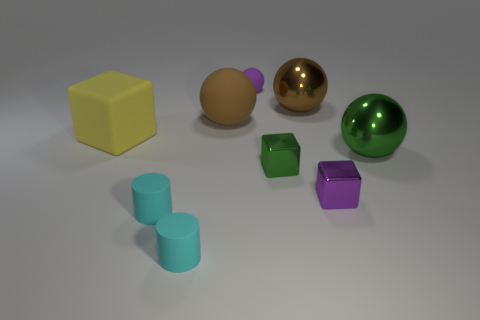What shape is the green thing that is left of the large shiny object that is behind the big block?
Ensure brevity in your answer.  Cube. There is another small object that is the same shape as the small green thing; what is its color?
Ensure brevity in your answer.  Purple. There is a big rubber ball; is its color the same as the large metal object that is behind the green sphere?
Offer a terse response. Yes. What shape is the metal object that is in front of the brown rubber ball and behind the small green object?
Your answer should be compact. Sphere. Is the number of green metallic spheres less than the number of cyan matte cylinders?
Offer a very short reply. Yes. Is there a red metal cylinder?
Ensure brevity in your answer.  No. What number of other objects are there of the same size as the purple shiny thing?
Offer a very short reply. 4. Are the big yellow block and the purple thing behind the large cube made of the same material?
Provide a short and direct response. Yes. Are there an equal number of purple rubber objects that are to the left of the large brown rubber object and purple objects that are in front of the large green object?
Make the answer very short. No. What is the small green block made of?
Offer a terse response. Metal. 